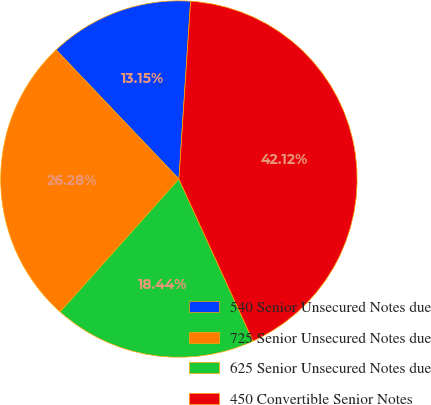Convert chart. <chart><loc_0><loc_0><loc_500><loc_500><pie_chart><fcel>540 Senior Unsecured Notes due<fcel>725 Senior Unsecured Notes due<fcel>625 Senior Unsecured Notes due<fcel>450 Convertible Senior Notes<nl><fcel>13.15%<fcel>26.28%<fcel>18.44%<fcel>42.12%<nl></chart> 